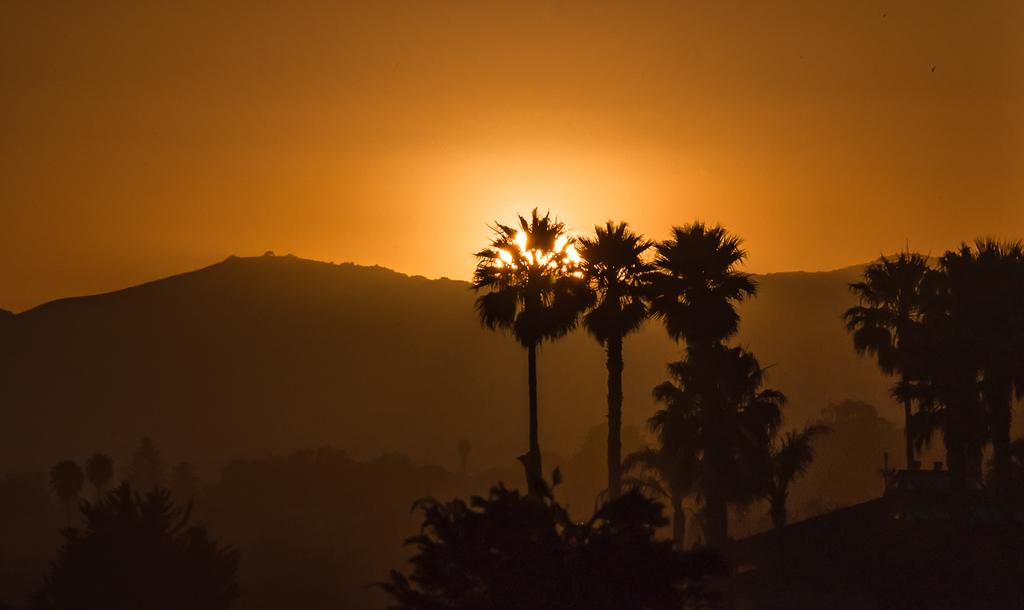What type of vegetation is in the foreground of the image? There are trees in the foreground of the image. What type of geological feature can be seen in the background of the image? There are cliffs in the background of the image. What celestial body is visible in the background of the image? The sun is visible in the background of the image. What else is visible in the background of the image? The sky is visible in the background of the image. Where is the lamp located in the image? There is no lamp present in the image. Can you describe the position of the pig in the image? There is no pig present in the image. 